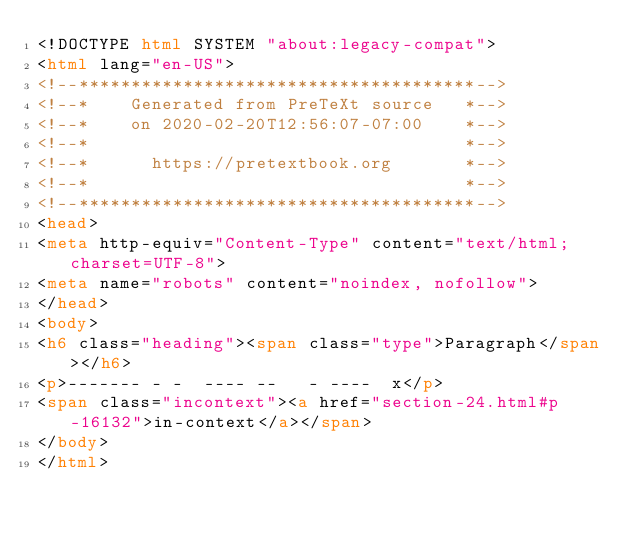<code> <loc_0><loc_0><loc_500><loc_500><_HTML_><!DOCTYPE html SYSTEM "about:legacy-compat">
<html lang="en-US">
<!--**************************************-->
<!--*    Generated from PreTeXt source   *-->
<!--*    on 2020-02-20T12:56:07-07:00    *-->
<!--*                                    *-->
<!--*      https://pretextbook.org       *-->
<!--*                                    *-->
<!--**************************************-->
<head>
<meta http-equiv="Content-Type" content="text/html; charset=UTF-8">
<meta name="robots" content="noindex, nofollow">
</head>
<body>
<h6 class="heading"><span class="type">Paragraph</span></h6>
<p>------- - -  ---- --   - ----  x</p>
<span class="incontext"><a href="section-24.html#p-16132">in-context</a></span>
</body>
</html>
</code> 